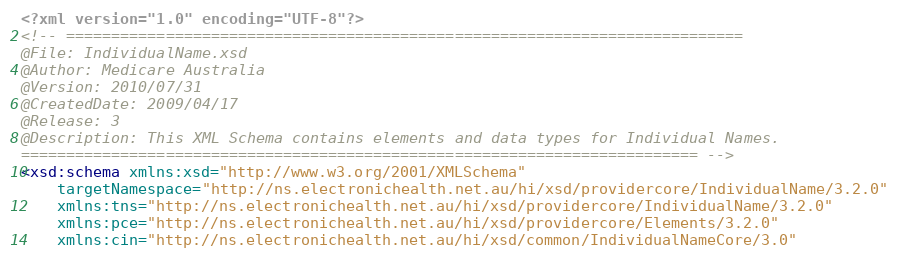<code> <loc_0><loc_0><loc_500><loc_500><_XML_><?xml version="1.0" encoding="UTF-8"?>
<!-- =========================================================================== 
@File: IndividualName.xsd 
@Author: Medicare Australia 
@Version: 2010/07/31 
@CreatedDate: 2009/04/17 
@Release: 3 
@Description: This XML Schema contains elements and data types for Individual Names. 
=========================================================================== -->
<xsd:schema xmlns:xsd="http://www.w3.org/2001/XMLSchema"
    targetNamespace="http://ns.electronichealth.net.au/hi/xsd/providercore/IndividualName/3.2.0"
    xmlns:tns="http://ns.electronichealth.net.au/hi/xsd/providercore/IndividualName/3.2.0"
    xmlns:pce="http://ns.electronichealth.net.au/hi/xsd/providercore/Elements/3.2.0"
    xmlns:cin="http://ns.electronichealth.net.au/hi/xsd/common/IndividualNameCore/3.0"</code> 